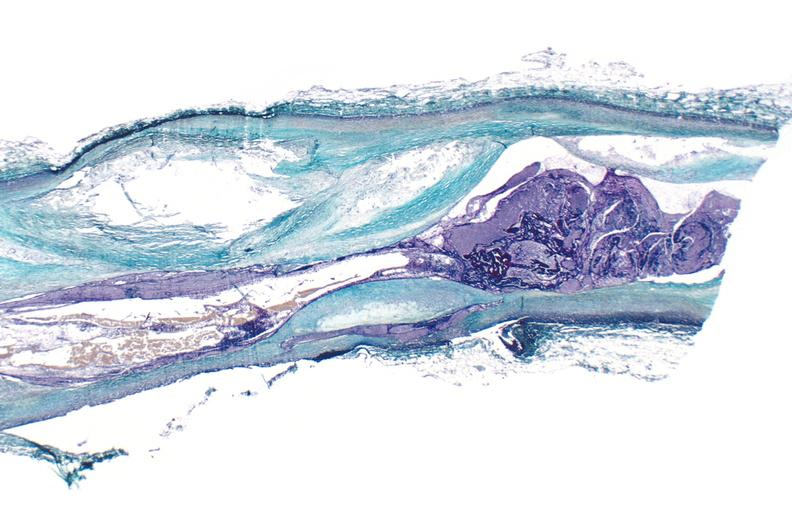what is present?
Answer the question using a single word or phrase. Urinary 